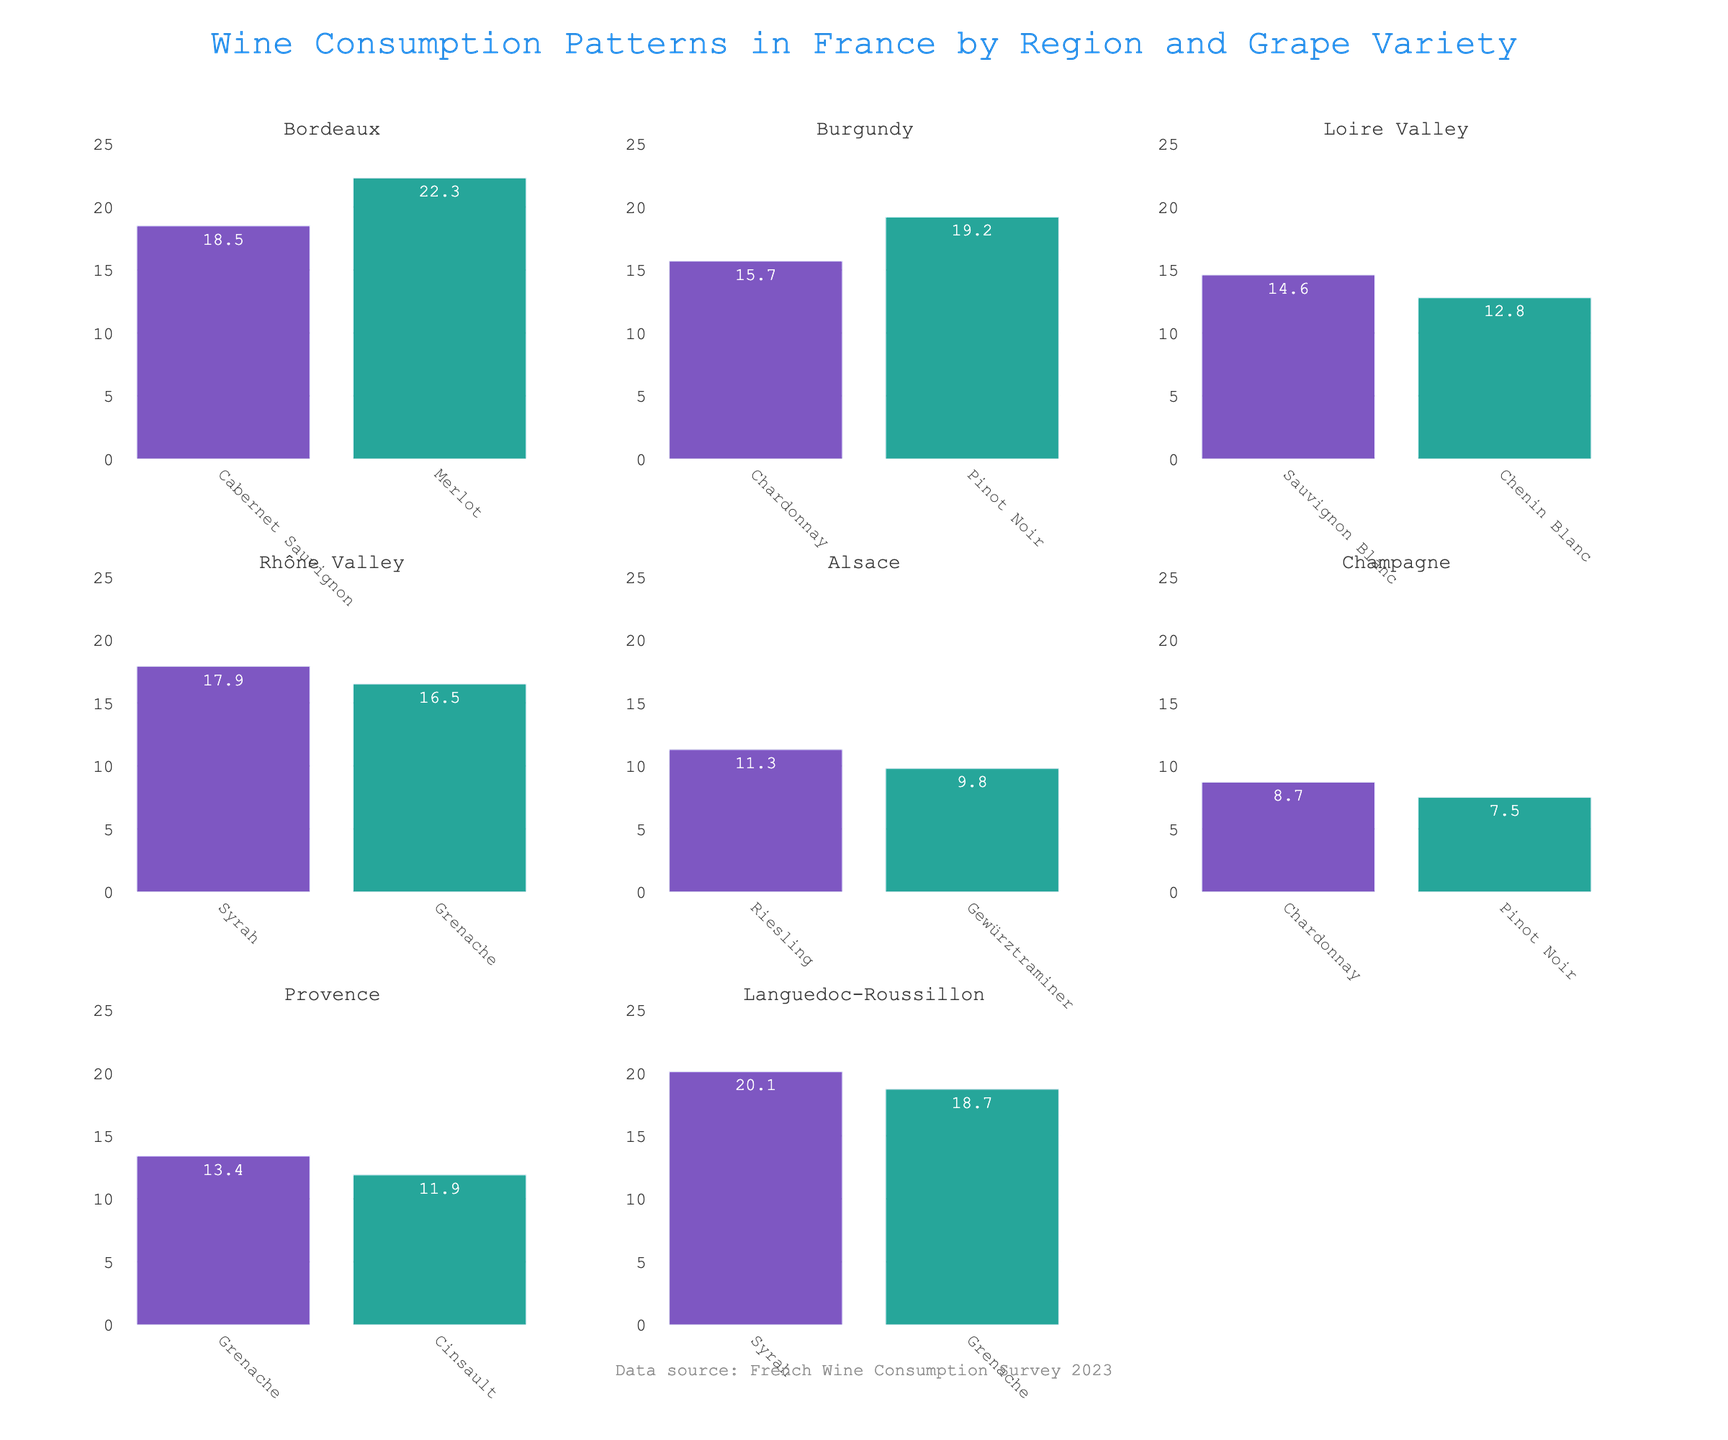What's the overall title of the figure? The overall title is shown at the top center of the figure. The text is "Wine Consumption Patterns in France by Region and Grape Variety".
Answer: Wine Consumption Patterns in France by Region and Grape Variety Which region has the highest consumption of Merlot? Locate the subplot titled with each region and find the respective bar for Merlot. The highest bar for Merlot appears in Bordeaux with a value of 22.3 L per capita.
Answer: Bordeaux What is the least consumed grape variety in Alsace? In the Alsace subplot, compare the heights of the bars representing Riesling and Gewürztraminer. Gewürztraminer has the lower value at 9.8 L per capita.
Answer: Gewürztraminer How much more Chardonnay is consumed in Burgundy compared to Champagne? Find the Chardonnay bar in both Burgundy and Champagne subplots. Subtract the value in Champagne (8.7 L) from the value in Burgundy (15.7 L): 15.7 - 8.7 = 7 L.
Answer: 7 L Which grape variety has the highest consumption in Rhône Valley? In the Rhône Valley subplot, compare the heights of the bars for Syrah and Grenache. Syrah has the highest value at 17.9 L per capita.
Answer: Syrah What is the average consumption of all grape varieties in Loire Valley? Loire Valley has two grape varieties: Sauvignon Blanc (14.6 L) and Chenin Blanc (12.8 L). Calculate their average: (14.6 + 12.8) / 2 = 13.7 L.
Answer: 13.7 L Is Syrah consumed more in Rhône Valley or Languedoc-Roussillon? Compare the consumption values of Syrah in the Rhône Valley subplot (17.9 L) and in the Languedoc-Roussillon subplot (20.1 L). Syrah is consumed more in Languedoc-Roussillon.
Answer: Languedoc-Roussillon How many regions have Chardonnay as a grape variety? Look for subplots with the label "Chardonnay". Bordeaux, Burgundy, and Champagne include Chardonnay, making it three regions.
Answer: 3 Between which regions is the consumption of Grenache nearly equal? Locate the Grenache bars across different subplots. Provence (13.4 L) and Rhône Valley (16.5 L) have closer consumption values compared to others.
Answer: Provence and Rhône Valley 